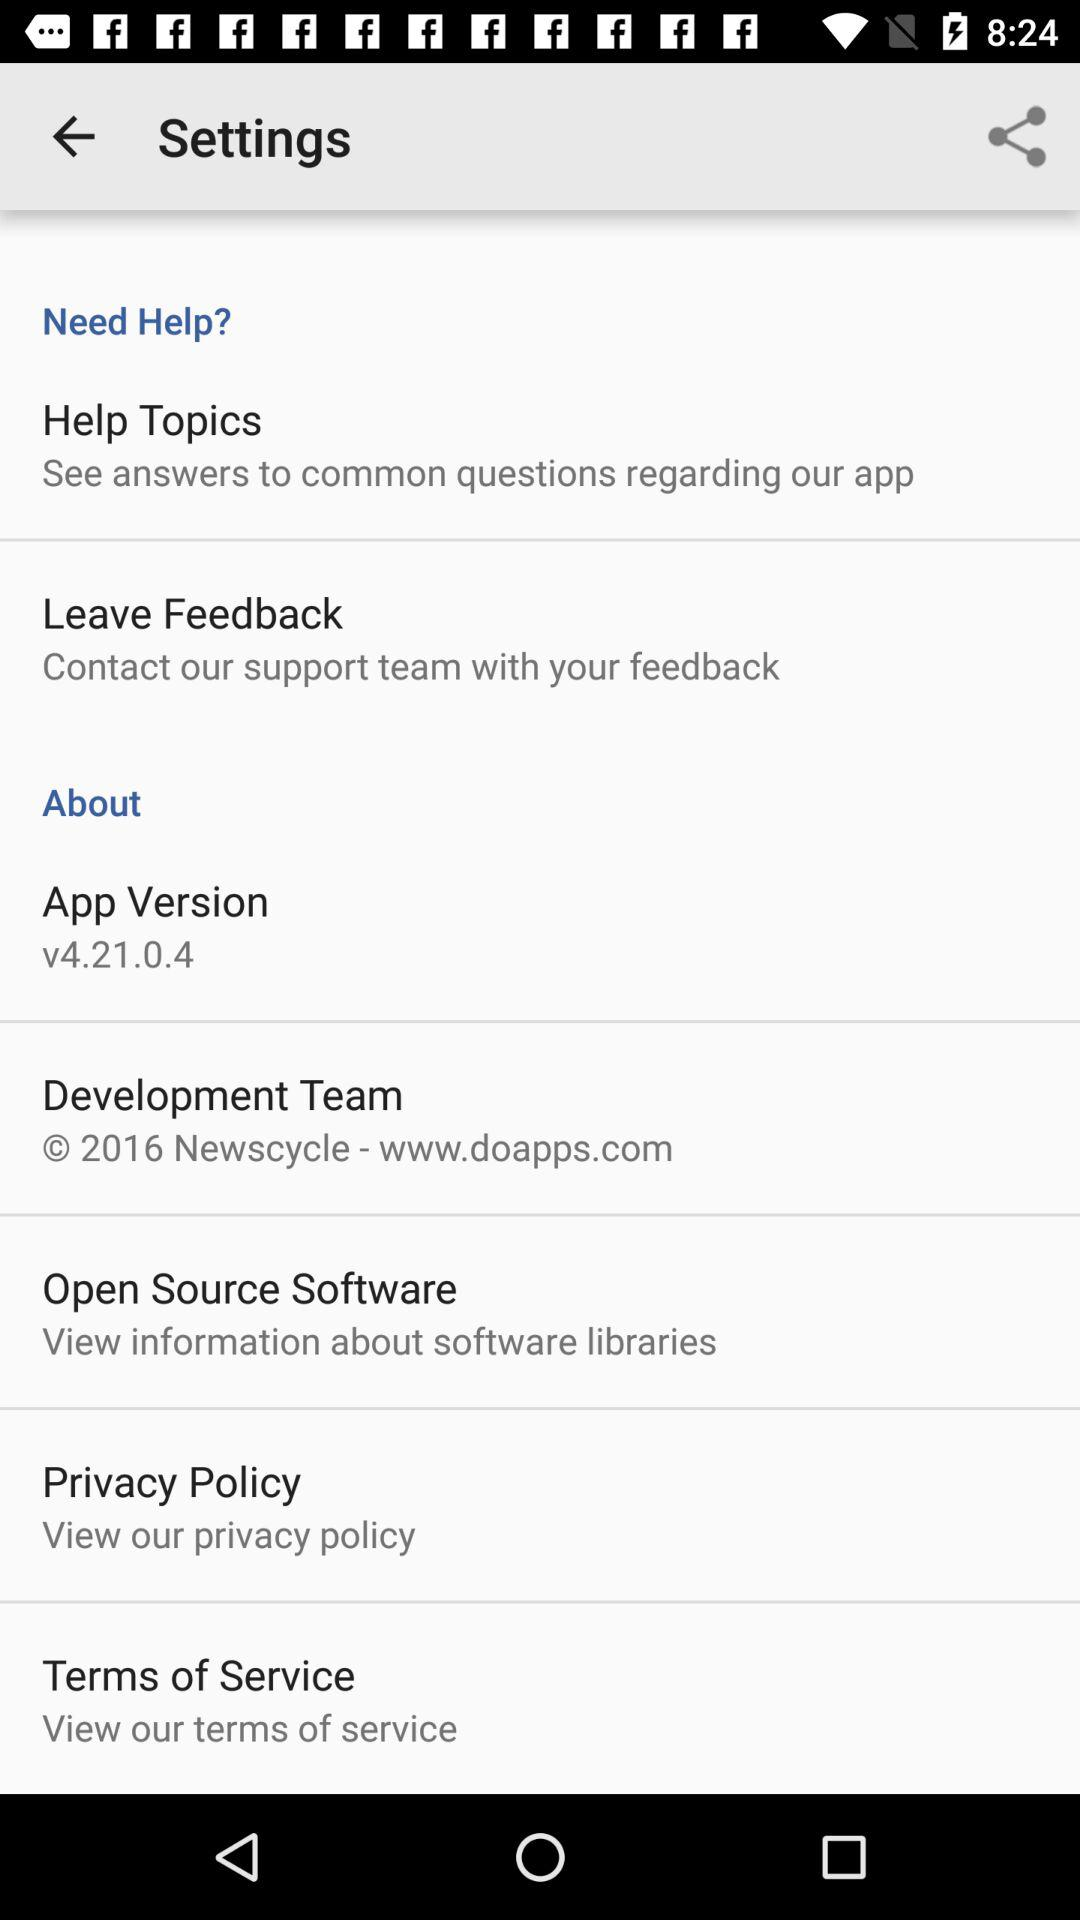What is the application version? The application version is v4.21.0.4. 